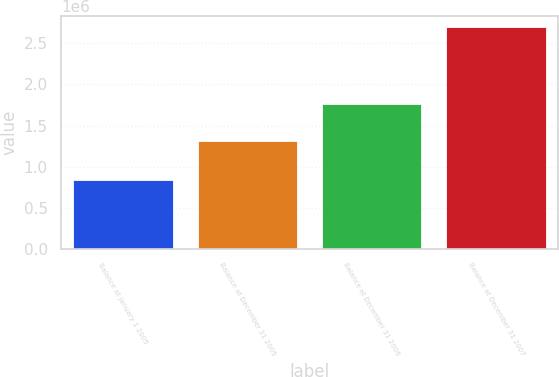<chart> <loc_0><loc_0><loc_500><loc_500><bar_chart><fcel>Balance at January 1 2005<fcel>Balance at December 31 2005<fcel>Balance at December 31 2006<fcel>Balance at December 31 2007<nl><fcel>839737<fcel>1.30585e+06<fcel>1.76012e+06<fcel>2.69933e+06<nl></chart> 